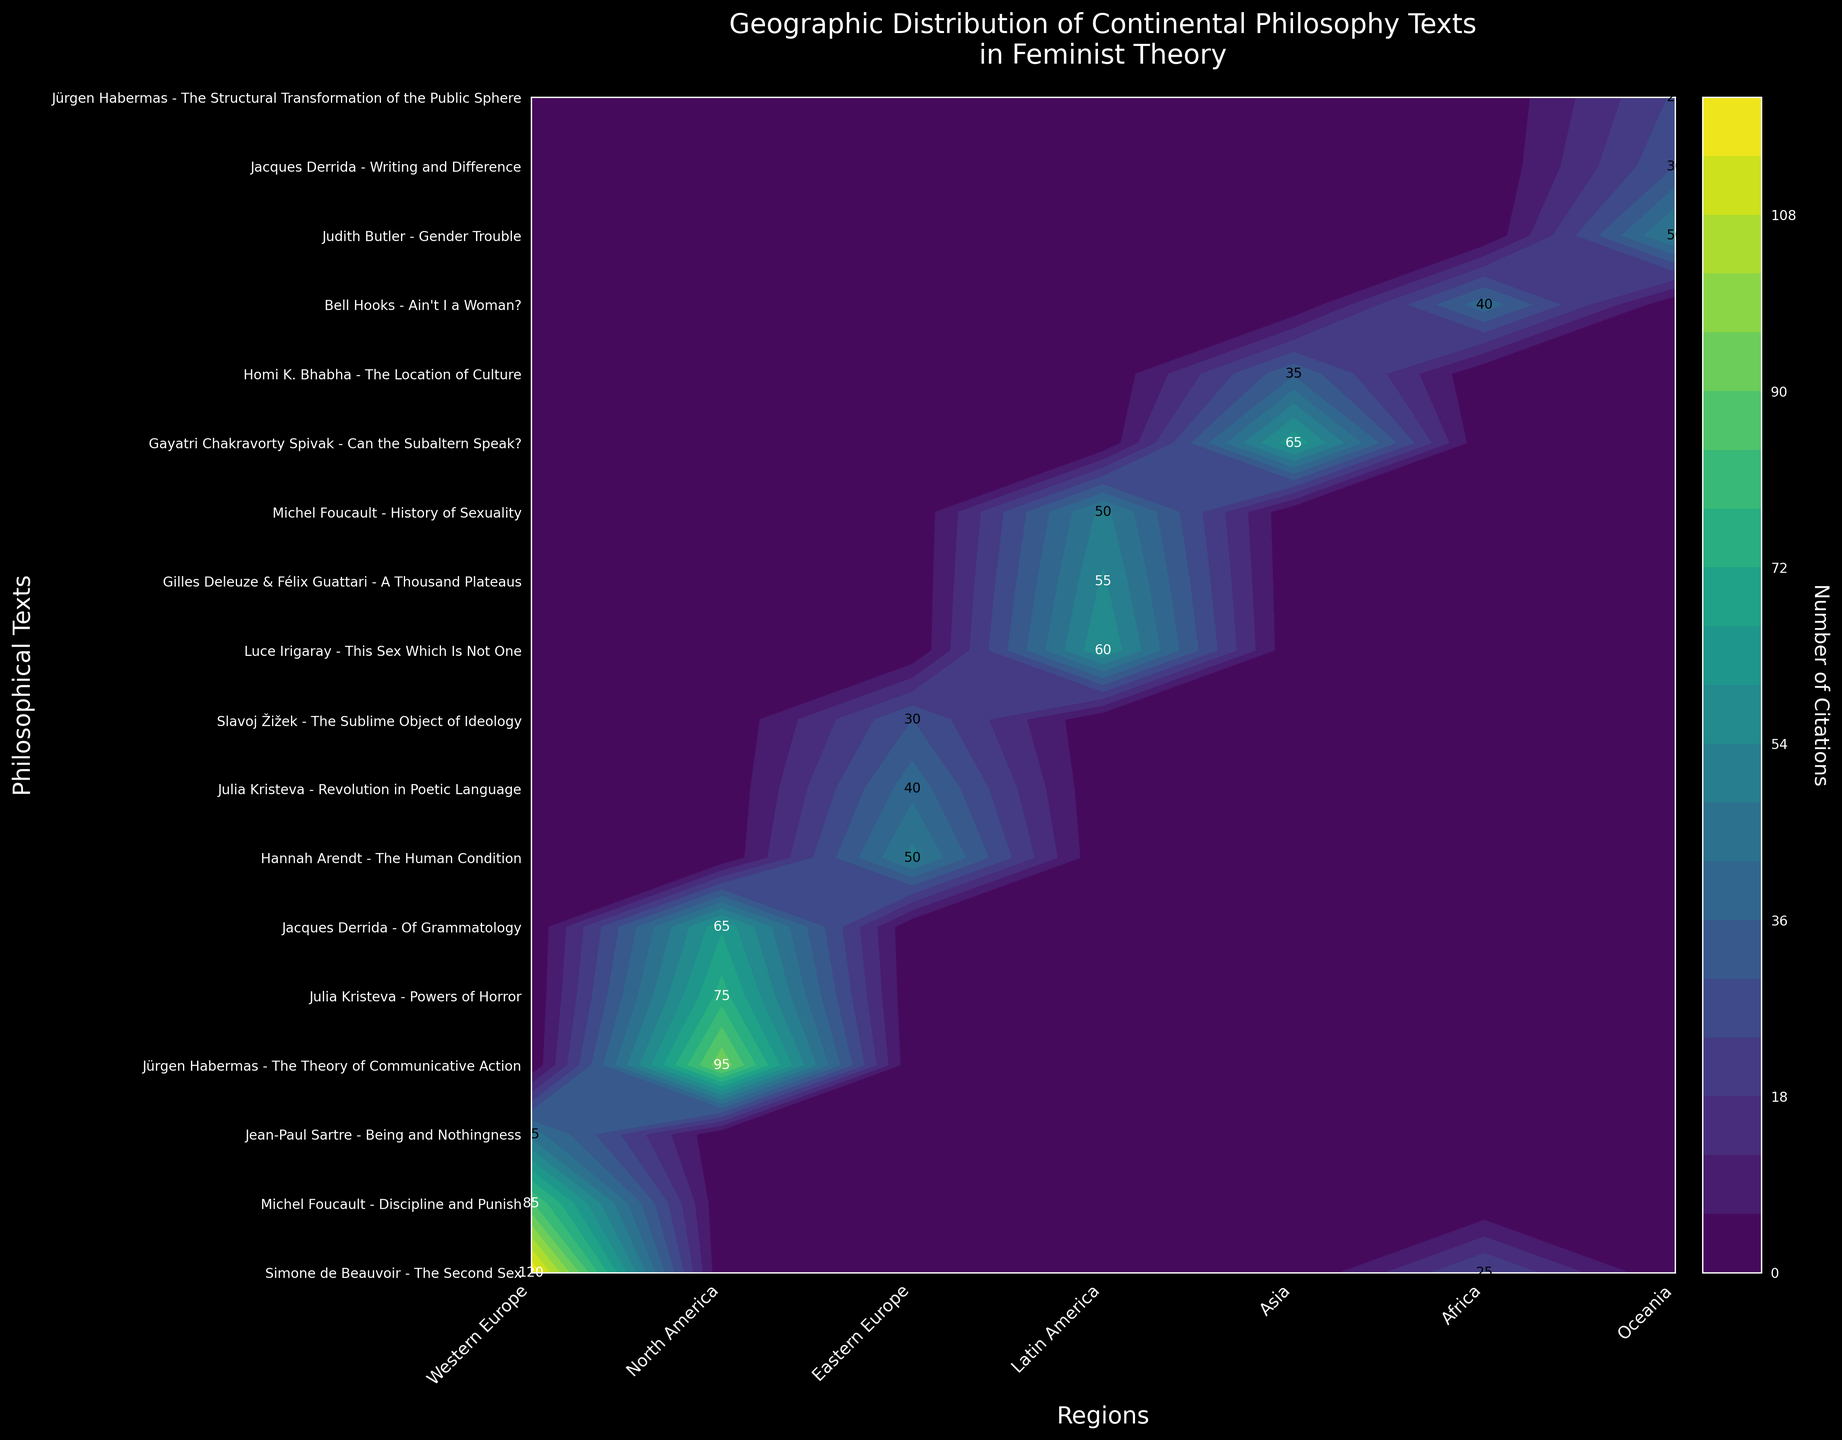What is the title of the figure? The title can be found at the top of the figure. It is typically the most prominent text and summarizes the main topic of the visualization.
Answer: Geographic Distribution of Continental Philosophy Texts in Feminist Theory Which region cites "The Second Sex" the most? Locate "The Second Sex" on the y-axis and identify the region on the x-axis that corresponds to the highest contour level. The annotation on the plot shows the number of citations.
Answer: Western Europe What text is cited 75 times in North America? Find the region "North America" on the x-axis and look horizontally across the contour plot to find the text on the y-axis where the number of citations is 75.
Answer: Powers of Horror How many citations does "Gender Trouble" have in Oceania? Locate "Gender Trouble" on the y-axis and find the corresponding value on the contour plot where it intersects with "Oceania" on the x-axis. The number is directly annotated on the plot.
Answer: 50 Which text has the most citations globally? By examining all the contour values annotated on the plot, identify the text with the highest number.
Answer: The Second Sex Compare the total citations of Jürgen Habermas and Michel Foucault. Sum up all citations for texts by Jürgen Habermas and Michel Foucault by visually comparing the numbers on the contour plot. Habermas: 95 + 25 = 120, Foucault: 85 + 50 = 135.
Answer: Foucault has more total citations Which region has the least number of citations for "The Human Condition"? Locate "The Human Condition" on the y-axis and compare the contour levels across all regions on the x-axis. The lowest number indicates the region with the least citations.
Answer: Africa (0 citations) What is the difference in citations between "Can the Subaltern Speak?" in Asia and Africa? Locate "Can the Subaltern Speak?" on the y-axis, then identify the contour values for Asia and Africa on the x-axis and compute the difference. Asia: 65, Africa: 0.
Answer: 65 Identify the region with the highest diversity in text citations. By examining the spread of contour levels (number of different texts cited) across each region, ascertain which region has the most diverse range of cited texts.
Answer: North America 